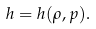Convert formula to latex. <formula><loc_0><loc_0><loc_500><loc_500>h = h ( \rho , p ) .</formula> 